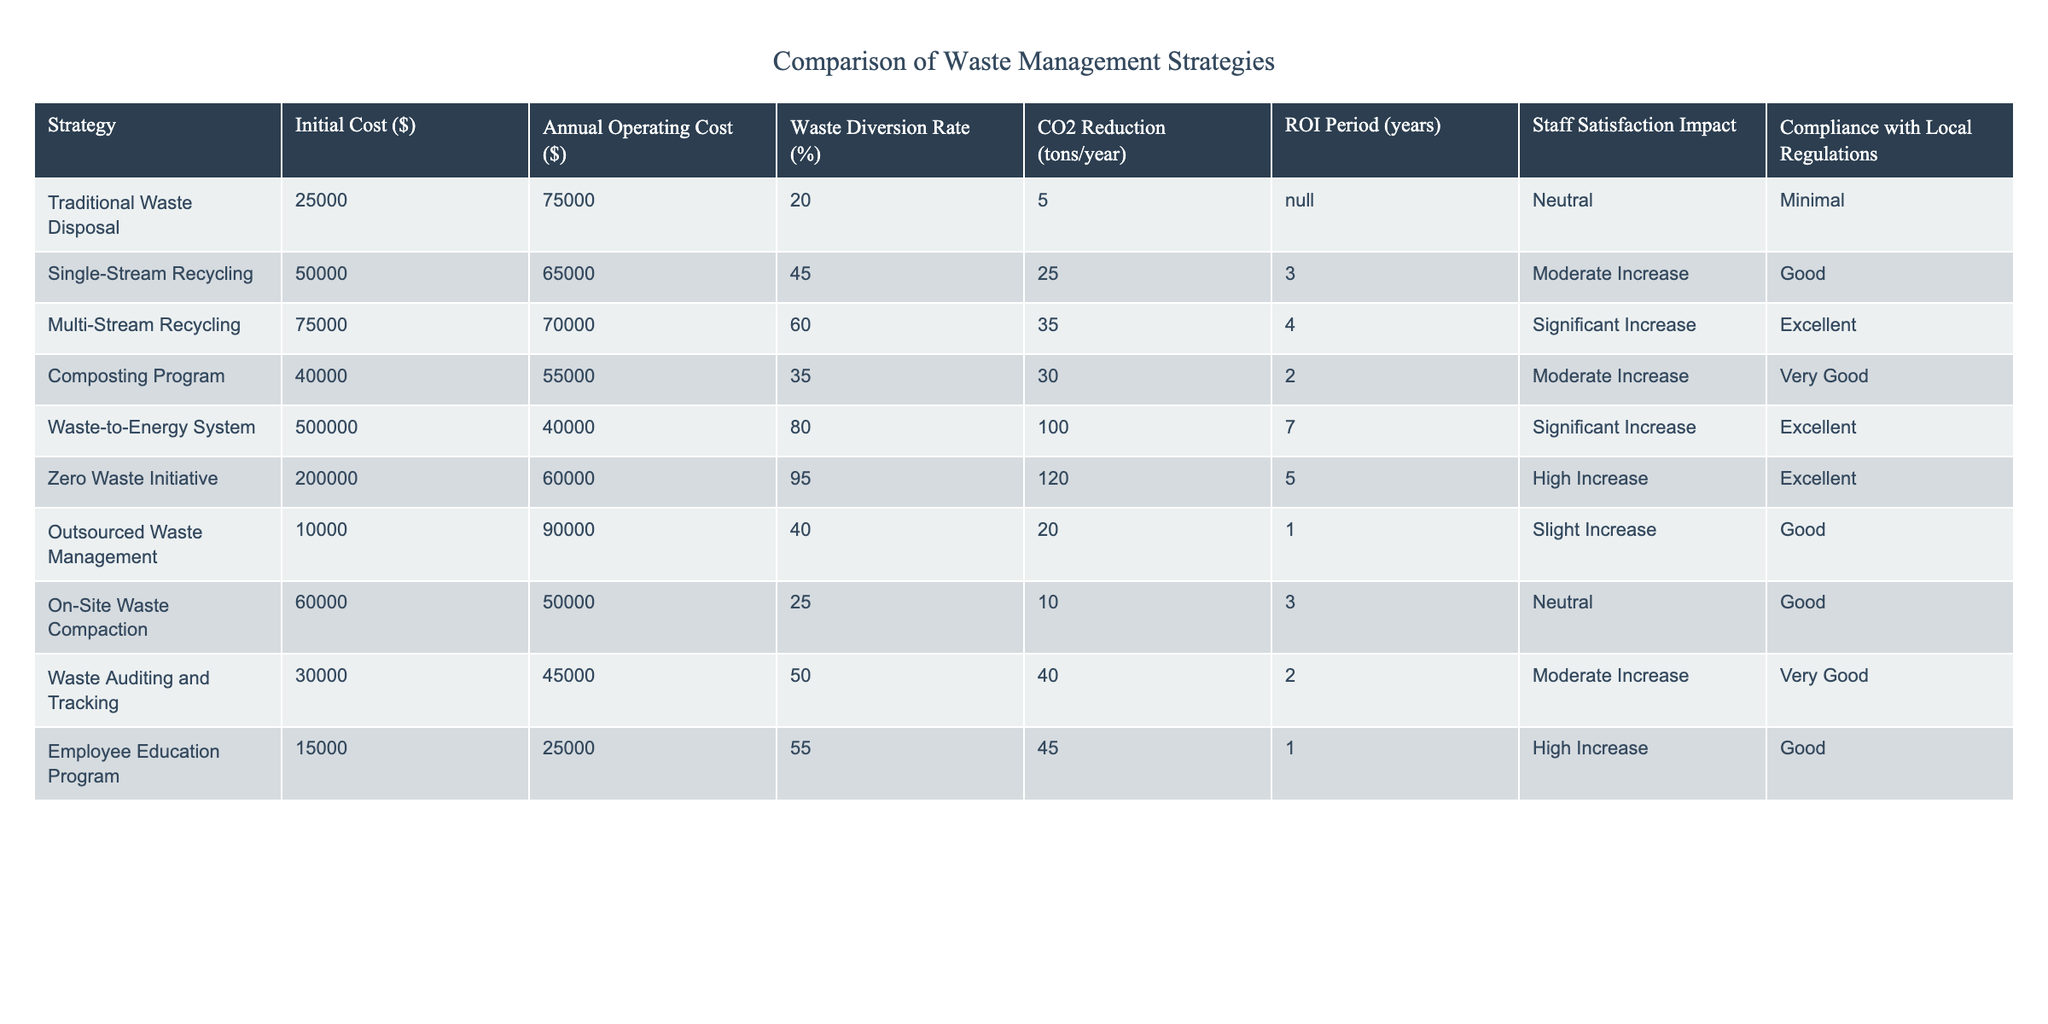What is the initial cost of the Waste-to-Energy System? The table lists the initial cost for each waste management strategy under the "Initial Cost ($)" column. For the Waste-to-Energy System, the value is 500,000.
Answer: 500,000 Which strategy has the highest annual operating cost? By looking at the "Annual Operating Cost ($)" column, we find that the Waste-to-Energy System has the highest cost at 40,000.
Answer: 40,000 What is the average waste diversion rate for Single-Stream Recycling and Multi-Stream Recycling? The waste diversion rates for these two strategies are 45% and 60%, respectively. To find the average, we add them: (45 + 60) = 105, and then divide by 2 to get 105/2 = 52.5.
Answer: 52.5 Is the Employee Education Program compliant with local regulations? The table indicates the compliance status for the Employee Education Program under "Compliance with Local Regulations." It states "Good," which confirms its compliance with local regulations.
Answer: Yes Which waste management strategy provides the quickest ROI period? Looking under the "ROI Period (years)" column, the Outsourced Waste Management has the shortest period at just 1 year.
Answer: 1 year What is the total CO2 reduction for all strategies combined? We total the "CO2 Reduction (tons/year)" values for each strategy: 5 + 25 + 35 + 30 + 100 + 120 + 20 + 10 + 40 + 45 = 420. The total CO2 reduction from all strategies is therefore 420 tons/year.
Answer: 420 tons/year Does the Composting Program's waste diversion rate exceed 30%? The Composting Program has a waste diversion rate of 35%, which is greater than 30%.
Answer: Yes What is the difference in annual operating cost between the Multi-Stream Recycling and the Outsourced Waste Management strategies? The Multi-Stream Recycling has an annual operating cost of 70,000, whereas the Outsourced Waste Management costs 90,000. To find the difference, we subtract: 90,000 - 70,000 = 20,000.
Answer: 20,000 Which strategy ranks the highest in staff satisfaction impact, and what is its classification? The chart shows that the Zero Waste Initiative has the highest staff satisfaction impact listed as "High Increase."
Answer: Zero Waste Initiative, High Increase 